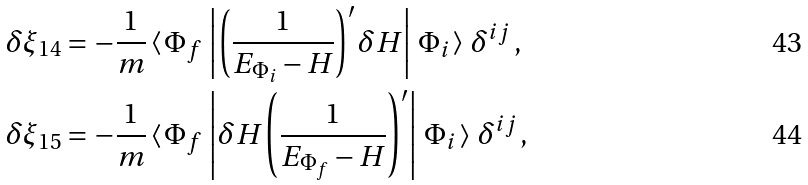<formula> <loc_0><loc_0><loc_500><loc_500>\delta \xi _ { 1 4 } & = - \frac { 1 } { m } \left < \, \Phi _ { f } \, \left | \left ( \frac { 1 } { E _ { \Phi _ { i } } - H } \right ) ^ { \prime } \delta H \right | \, \Phi _ { i } \, \right > \, \delta ^ { i j } \, , \\ \delta \xi _ { 1 5 } & = - \frac { 1 } { m } \left < \, \Phi _ { f } \, \left | \delta H \left ( \frac { 1 } { E _ { \Phi _ { f } } - H } \right ) ^ { \prime } \right | \, \Phi _ { i } \, \right > \, \delta ^ { i j } \, ,</formula> 